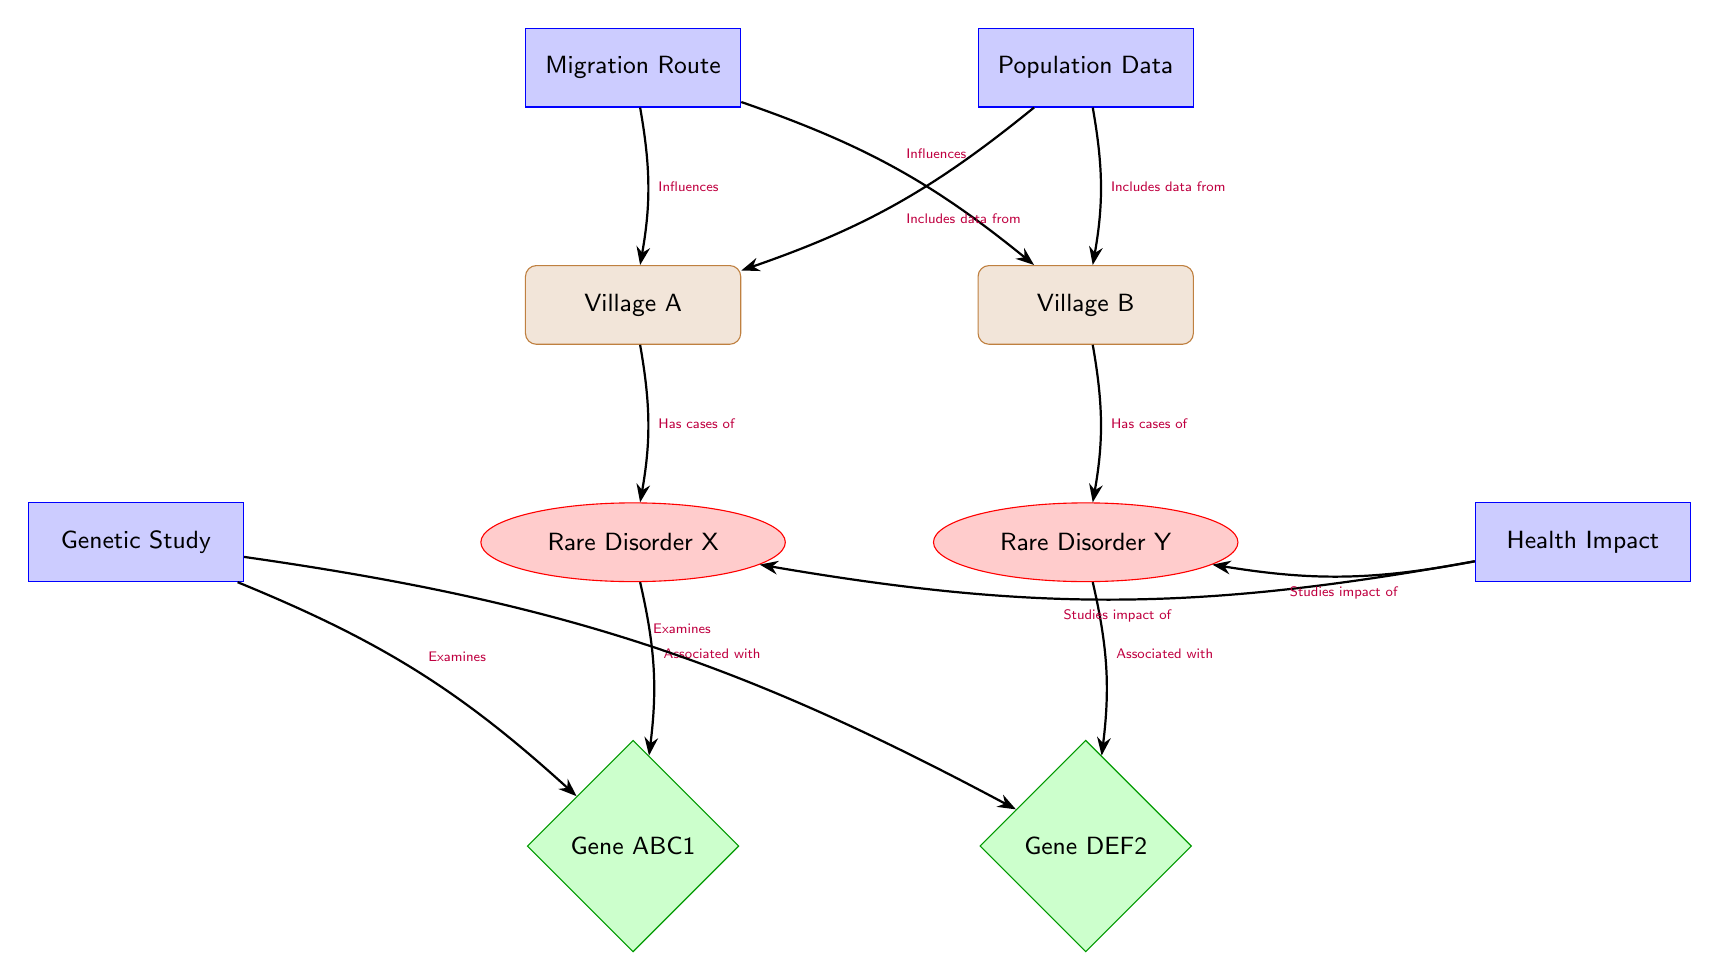What are the names of the villages depicted in the diagram? The diagram displays two villages: Village A and Village B. These nodes are labeled directly, allowing easy identification of their names.
Answer: Village A, Village B Which rare disorder is associated with Gene ABC1? The diagram indicates that Rare Disorder X is associated with Gene ABC1, as there is a directed edge connecting the two nodes, specifying this relationship.
Answer: Rare Disorder X How many rare disorders are mentioned in the diagram? There are two rare disorders depicted in the diagram: Rare Disorder X and Rare Disorder Y. Counting these nodes provides the answer.
Answer: 2 What influences both Village A and Village B according to the diagram? The diagram clearly shows that the Migration Route influences both Village A and Village B, indicated by outgoing edges from the Migration Route node to both villages.
Answer: Migration Route Which health impact is studied in relation to Rare Disorder Y? The diagram shows that the Health Impact node studies the impact of Rare Disorder Y. This relationship is defined by an edge connecting Health Impact to Rare Disorder Y.
Answer: Rare Disorder Y How is the population data connected to the villages? The population data includes information from both villages, as indicated by the directed edges from the population data node to both Village A and Village B.
Answer: Includes data from both villages Which gene is associated with Rare Disorder Y? The diagram shows that Gene DEF2 is associated with Rare Disorder Y. This association is represented by a directed edge connecting the two nodes.
Answer: Gene DEF2 What type of studies does the genetic study examine in relation to the rare disorders? The genetic study examines both Gene ABC1 and Gene DEF2, as indicated by the directed edges leading from the genetic study node to both gene nodes.
Answer: Examines both genes What is the primary connection between migration route and villages in the diagram? The primary connection is that the migration route influences both Village A and Village B, as shown by the directed edges originating from the migration route node.
Answer: Influences both villages 